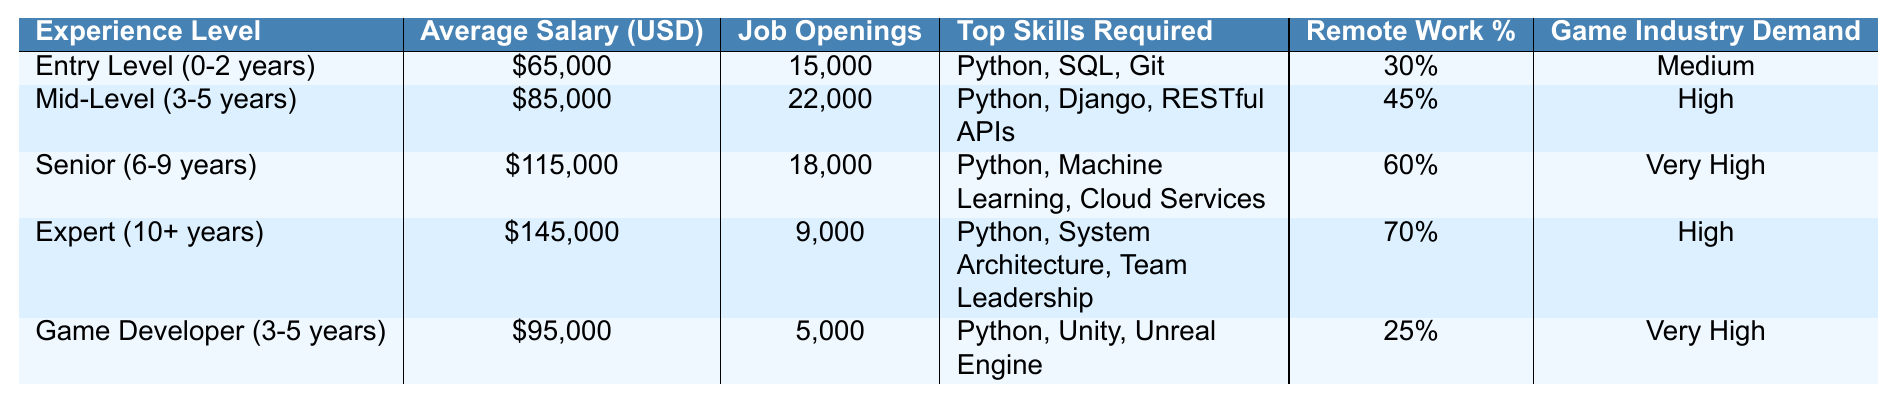What is the average salary for Senior-level positions? According to the table, the average salary for Senior positions (6-9 years of experience) is listed as $115,000.
Answer: $115,000 How many job openings are available for Mid-Level (3-5 years) positions? The table indicates that there are 22,000 job openings available for Mid-Level positions, which is stated directly in the relevant row.
Answer: 22,000 Does the Game Developer position require more or fewer years of experience compared to the Senior position? The Game Developer position requires 3-5 years of experience, while the Senior position requires 6-9 years. Therefore, the Senior position requires more years of experience.
Answer: More What is the difference in average salary between Expert-level and Entry-level positions? The average salary for Expert-level positions is $145,000, and for Entry-level positions, it is $65,000. The difference is calculated as $145,000 - $65,000 = $80,000.
Answer: $80,000 Is the percentage of remote work higher for Senior-level positions than for Entry-level positions? The remote work percentage for Senior-level positions is 60%, and for Entry-level positions, it is 30%. Since 60% is greater than 30%, the statement is true.
Answer: Yes Which experience level has the highest demand in the game industry? According to the table, the Senior position has a "Very High" demand in the game industry, which is the highest level indicated for any row.
Answer: Senior (6-9 years) What is the total number of job openings for Mid-Level and Senior positions combined? The number of job openings for Mid-Level positions is 22,000 and for Senior positions is 18,000. The total is calculated as 22,000 + 18,000 = 40,000.
Answer: 40,000 Is the average salary for Game Developers higher or lower than that for Mid-Level positions? The average salary for Game Developers is $95,000, while the average salary for Mid-Level positions is $85,000. Since $95,000 is greater than $85,000, the Game Developer position pays more.
Answer: Higher What percentage of remote work is common for Expert-level positions? The table indicates that Expert-level positions allow for 70% of remote work, as directly stated in the corresponding row.
Answer: 70% If you were to arrange all experience levels by average salary in ascending order, which position would come second? The average salaries in ascending order are: Entry Level ($65,000), Mid-Level ($85,000), Game Developer ($95,000), Senior ($115,000), and Expert ($145,000). Therefore, the second position is Mid-Level.
Answer: Mid-Level (3-5 years) 